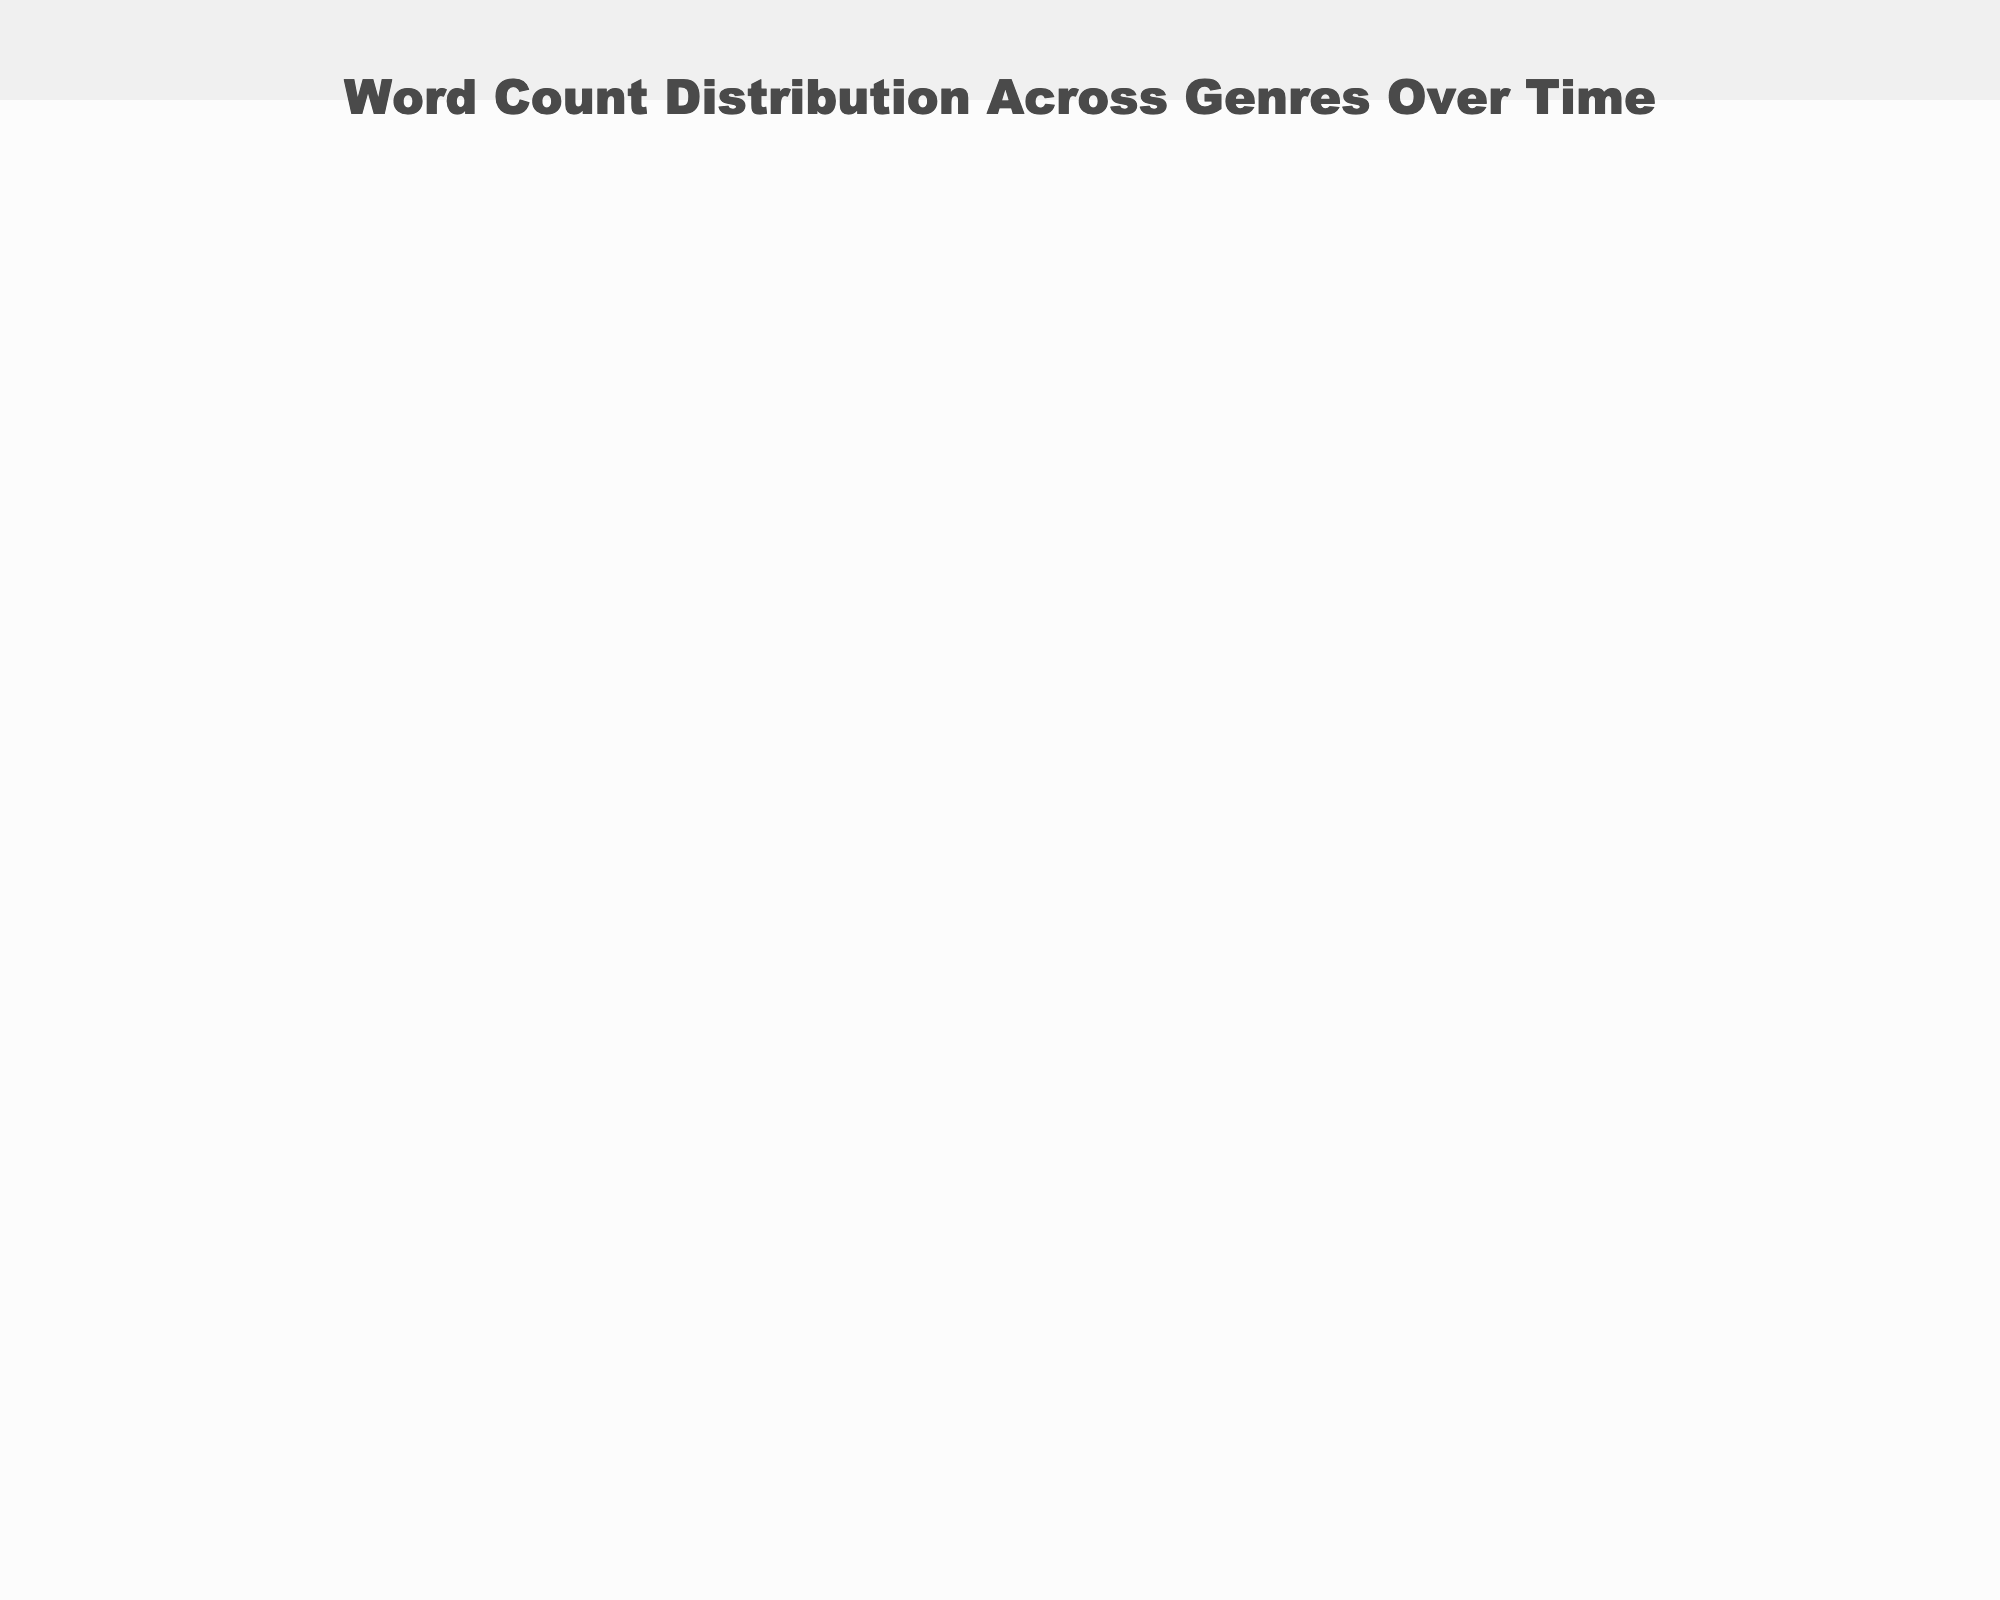What is the title of the figure? The title is usually positioned at the top center of the figure, and from the provided code, it is explicitly set.
Answer: Word Count Distribution Across Genres Over Time What are the axis titles in this figure? The axis titles are typically labeled along each axis and are explicitly set in the code as well.
Answer: Year for x-axis, Genre for y-axis, and Average Word Count for z-axis What color scale is used for the plot? The color scale defines the range of colors used in the plot to represent different values. From the code, this is explicitly set.
Answer: Viridis Which genre had the highest average word count in 2020? To find the highest average word count for 2020, we look at the z-values for the year 2020 across all genres in the plot. Science Fiction has the highest value.
Answer: Science Fiction How does the average word count for Romance change from 1950 to 2020? Identify the z-values for the Romance genre for the years from 1950 to 2020 and observe the trend. It increases from 65,000 in 1950 to 90,000 in 2020.
Answer: It increases In 1990, which genre had a higher average word count: Mystery or Romance? Compare the z-values for Mystery and Romance in the year 1990. Mystery has 75,000 while Romance has 80,000.
Answer: Romance What is the difference in average word count between Science Fiction and Mystery in 2010? Find the z-values for Science Fiction and Mystery in the year 2010 and subtract the Mystery value from the Science Fiction value. 120,000 - 80,000 = 40,000.
Answer: 40,000 Which genre shows the most considerable increase in average word count from 1950 to 2020? Calculate the increase for each genre from 1950 to 2020 and compare them. Science Fiction increases from 75,000 to 130,000, which is the largest increase (55,000).
Answer: Science Fiction Between which consecutive decades does Science Fiction see the highest jump in average word count? Check the z-values for Science Fiction for each successive decade and identify the largest increase. The highest jump is between 1970 (90,000) and 1990 (110,000), a difference of 20,000.
Answer: 1970 to 1990 